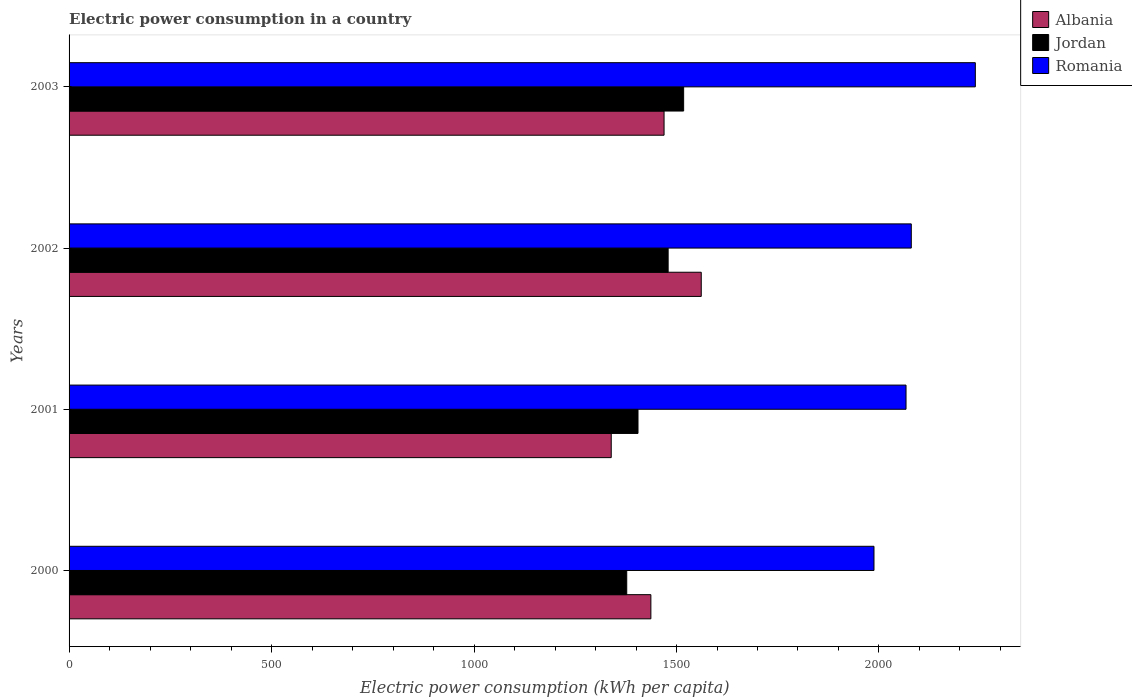How many different coloured bars are there?
Your response must be concise. 3. Are the number of bars per tick equal to the number of legend labels?
Provide a short and direct response. Yes. Are the number of bars on each tick of the Y-axis equal?
Keep it short and to the point. Yes. How many bars are there on the 2nd tick from the top?
Give a very brief answer. 3. What is the label of the 1st group of bars from the top?
Make the answer very short. 2003. What is the electric power consumption in in Romania in 2002?
Keep it short and to the point. 2079.8. Across all years, what is the maximum electric power consumption in in Romania?
Your answer should be compact. 2237.94. Across all years, what is the minimum electric power consumption in in Albania?
Give a very brief answer. 1338.81. What is the total electric power consumption in in Albania in the graph?
Provide a succinct answer. 5805.9. What is the difference between the electric power consumption in in Albania in 2000 and that in 2001?
Ensure brevity in your answer.  97.89. What is the difference between the electric power consumption in in Romania in 2001 and the electric power consumption in in Albania in 2003?
Your response must be concise. 597.52. What is the average electric power consumption in in Romania per year?
Provide a short and direct response. 2093.04. In the year 2000, what is the difference between the electric power consumption in in Albania and electric power consumption in in Jordan?
Your answer should be compact. 59.59. In how many years, is the electric power consumption in in Albania greater than 1800 kWh per capita?
Your answer should be very brief. 0. What is the ratio of the electric power consumption in in Albania in 2000 to that in 2003?
Offer a very short reply. 0.98. Is the difference between the electric power consumption in in Albania in 2000 and 2002 greater than the difference between the electric power consumption in in Jordan in 2000 and 2002?
Offer a terse response. No. What is the difference between the highest and the second highest electric power consumption in in Albania?
Keep it short and to the point. 91.86. What is the difference between the highest and the lowest electric power consumption in in Jordan?
Your response must be concise. 140.51. Is the sum of the electric power consumption in in Albania in 2000 and 2003 greater than the maximum electric power consumption in in Romania across all years?
Offer a very short reply. Yes. What does the 3rd bar from the top in 2000 represents?
Keep it short and to the point. Albania. What does the 2nd bar from the bottom in 2001 represents?
Ensure brevity in your answer.  Jordan. How many bars are there?
Provide a short and direct response. 12. Are all the bars in the graph horizontal?
Your answer should be very brief. Yes. How many years are there in the graph?
Your response must be concise. 4. What is the difference between two consecutive major ticks on the X-axis?
Provide a succinct answer. 500. Are the values on the major ticks of X-axis written in scientific E-notation?
Keep it short and to the point. No. Does the graph contain any zero values?
Your response must be concise. No. Does the graph contain grids?
Your answer should be very brief. No. Where does the legend appear in the graph?
Your answer should be very brief. Top right. How many legend labels are there?
Your answer should be very brief. 3. What is the title of the graph?
Provide a short and direct response. Electric power consumption in a country. Does "Benin" appear as one of the legend labels in the graph?
Make the answer very short. No. What is the label or title of the X-axis?
Offer a very short reply. Electric power consumption (kWh per capita). What is the label or title of the Y-axis?
Provide a short and direct response. Years. What is the Electric power consumption (kWh per capita) in Albania in 2000?
Give a very brief answer. 1436.7. What is the Electric power consumption (kWh per capita) of Jordan in 2000?
Give a very brief answer. 1377.11. What is the Electric power consumption (kWh per capita) in Romania in 2000?
Provide a short and direct response. 1987.66. What is the Electric power consumption (kWh per capita) in Albania in 2001?
Offer a very short reply. 1338.81. What is the Electric power consumption (kWh per capita) of Jordan in 2001?
Give a very brief answer. 1404.92. What is the Electric power consumption (kWh per capita) of Romania in 2001?
Your answer should be very brief. 2066.78. What is the Electric power consumption (kWh per capita) of Albania in 2002?
Offer a terse response. 1561.12. What is the Electric power consumption (kWh per capita) in Jordan in 2002?
Provide a succinct answer. 1479.36. What is the Electric power consumption (kWh per capita) in Romania in 2002?
Give a very brief answer. 2079.8. What is the Electric power consumption (kWh per capita) of Albania in 2003?
Provide a short and direct response. 1469.26. What is the Electric power consumption (kWh per capita) in Jordan in 2003?
Your answer should be compact. 1517.62. What is the Electric power consumption (kWh per capita) of Romania in 2003?
Offer a very short reply. 2237.94. Across all years, what is the maximum Electric power consumption (kWh per capita) of Albania?
Keep it short and to the point. 1561.12. Across all years, what is the maximum Electric power consumption (kWh per capita) in Jordan?
Your response must be concise. 1517.62. Across all years, what is the maximum Electric power consumption (kWh per capita) in Romania?
Give a very brief answer. 2237.94. Across all years, what is the minimum Electric power consumption (kWh per capita) of Albania?
Offer a very short reply. 1338.81. Across all years, what is the minimum Electric power consumption (kWh per capita) of Jordan?
Offer a very short reply. 1377.11. Across all years, what is the minimum Electric power consumption (kWh per capita) of Romania?
Your answer should be compact. 1987.66. What is the total Electric power consumption (kWh per capita) of Albania in the graph?
Keep it short and to the point. 5805.9. What is the total Electric power consumption (kWh per capita) in Jordan in the graph?
Ensure brevity in your answer.  5779.01. What is the total Electric power consumption (kWh per capita) of Romania in the graph?
Make the answer very short. 8372.18. What is the difference between the Electric power consumption (kWh per capita) of Albania in 2000 and that in 2001?
Your answer should be very brief. 97.89. What is the difference between the Electric power consumption (kWh per capita) in Jordan in 2000 and that in 2001?
Your answer should be very brief. -27.81. What is the difference between the Electric power consumption (kWh per capita) in Romania in 2000 and that in 2001?
Keep it short and to the point. -79.12. What is the difference between the Electric power consumption (kWh per capita) of Albania in 2000 and that in 2002?
Provide a short and direct response. -124.42. What is the difference between the Electric power consumption (kWh per capita) of Jordan in 2000 and that in 2002?
Provide a succinct answer. -102.25. What is the difference between the Electric power consumption (kWh per capita) of Romania in 2000 and that in 2002?
Ensure brevity in your answer.  -92.14. What is the difference between the Electric power consumption (kWh per capita) of Albania in 2000 and that in 2003?
Provide a succinct answer. -32.57. What is the difference between the Electric power consumption (kWh per capita) in Jordan in 2000 and that in 2003?
Your answer should be very brief. -140.51. What is the difference between the Electric power consumption (kWh per capita) in Romania in 2000 and that in 2003?
Make the answer very short. -250.28. What is the difference between the Electric power consumption (kWh per capita) in Albania in 2001 and that in 2002?
Offer a very short reply. -222.31. What is the difference between the Electric power consumption (kWh per capita) in Jordan in 2001 and that in 2002?
Offer a terse response. -74.44. What is the difference between the Electric power consumption (kWh per capita) of Romania in 2001 and that in 2002?
Your answer should be compact. -13.01. What is the difference between the Electric power consumption (kWh per capita) in Albania in 2001 and that in 2003?
Your answer should be very brief. -130.45. What is the difference between the Electric power consumption (kWh per capita) of Jordan in 2001 and that in 2003?
Offer a terse response. -112.7. What is the difference between the Electric power consumption (kWh per capita) in Romania in 2001 and that in 2003?
Keep it short and to the point. -171.15. What is the difference between the Electric power consumption (kWh per capita) in Albania in 2002 and that in 2003?
Keep it short and to the point. 91.86. What is the difference between the Electric power consumption (kWh per capita) in Jordan in 2002 and that in 2003?
Offer a very short reply. -38.27. What is the difference between the Electric power consumption (kWh per capita) of Romania in 2002 and that in 2003?
Make the answer very short. -158.14. What is the difference between the Electric power consumption (kWh per capita) in Albania in 2000 and the Electric power consumption (kWh per capita) in Jordan in 2001?
Keep it short and to the point. 31.78. What is the difference between the Electric power consumption (kWh per capita) in Albania in 2000 and the Electric power consumption (kWh per capita) in Romania in 2001?
Offer a terse response. -630.09. What is the difference between the Electric power consumption (kWh per capita) of Jordan in 2000 and the Electric power consumption (kWh per capita) of Romania in 2001?
Offer a terse response. -689.67. What is the difference between the Electric power consumption (kWh per capita) in Albania in 2000 and the Electric power consumption (kWh per capita) in Jordan in 2002?
Offer a very short reply. -42.66. What is the difference between the Electric power consumption (kWh per capita) in Albania in 2000 and the Electric power consumption (kWh per capita) in Romania in 2002?
Your answer should be very brief. -643.1. What is the difference between the Electric power consumption (kWh per capita) of Jordan in 2000 and the Electric power consumption (kWh per capita) of Romania in 2002?
Ensure brevity in your answer.  -702.69. What is the difference between the Electric power consumption (kWh per capita) of Albania in 2000 and the Electric power consumption (kWh per capita) of Jordan in 2003?
Provide a succinct answer. -80.92. What is the difference between the Electric power consumption (kWh per capita) in Albania in 2000 and the Electric power consumption (kWh per capita) in Romania in 2003?
Ensure brevity in your answer.  -801.24. What is the difference between the Electric power consumption (kWh per capita) in Jordan in 2000 and the Electric power consumption (kWh per capita) in Romania in 2003?
Your answer should be compact. -860.83. What is the difference between the Electric power consumption (kWh per capita) of Albania in 2001 and the Electric power consumption (kWh per capita) of Jordan in 2002?
Make the answer very short. -140.54. What is the difference between the Electric power consumption (kWh per capita) in Albania in 2001 and the Electric power consumption (kWh per capita) in Romania in 2002?
Keep it short and to the point. -740.98. What is the difference between the Electric power consumption (kWh per capita) in Jordan in 2001 and the Electric power consumption (kWh per capita) in Romania in 2002?
Your response must be concise. -674.87. What is the difference between the Electric power consumption (kWh per capita) in Albania in 2001 and the Electric power consumption (kWh per capita) in Jordan in 2003?
Ensure brevity in your answer.  -178.81. What is the difference between the Electric power consumption (kWh per capita) of Albania in 2001 and the Electric power consumption (kWh per capita) of Romania in 2003?
Provide a succinct answer. -899.12. What is the difference between the Electric power consumption (kWh per capita) of Jordan in 2001 and the Electric power consumption (kWh per capita) of Romania in 2003?
Your answer should be very brief. -833.02. What is the difference between the Electric power consumption (kWh per capita) in Albania in 2002 and the Electric power consumption (kWh per capita) in Jordan in 2003?
Make the answer very short. 43.5. What is the difference between the Electric power consumption (kWh per capita) in Albania in 2002 and the Electric power consumption (kWh per capita) in Romania in 2003?
Offer a terse response. -676.82. What is the difference between the Electric power consumption (kWh per capita) of Jordan in 2002 and the Electric power consumption (kWh per capita) of Romania in 2003?
Your answer should be very brief. -758.58. What is the average Electric power consumption (kWh per capita) of Albania per year?
Give a very brief answer. 1451.47. What is the average Electric power consumption (kWh per capita) in Jordan per year?
Provide a succinct answer. 1444.75. What is the average Electric power consumption (kWh per capita) of Romania per year?
Provide a short and direct response. 2093.04. In the year 2000, what is the difference between the Electric power consumption (kWh per capita) of Albania and Electric power consumption (kWh per capita) of Jordan?
Your response must be concise. 59.59. In the year 2000, what is the difference between the Electric power consumption (kWh per capita) in Albania and Electric power consumption (kWh per capita) in Romania?
Give a very brief answer. -550.96. In the year 2000, what is the difference between the Electric power consumption (kWh per capita) of Jordan and Electric power consumption (kWh per capita) of Romania?
Your answer should be very brief. -610.55. In the year 2001, what is the difference between the Electric power consumption (kWh per capita) in Albania and Electric power consumption (kWh per capita) in Jordan?
Make the answer very short. -66.11. In the year 2001, what is the difference between the Electric power consumption (kWh per capita) of Albania and Electric power consumption (kWh per capita) of Romania?
Your answer should be compact. -727.97. In the year 2001, what is the difference between the Electric power consumption (kWh per capita) in Jordan and Electric power consumption (kWh per capita) in Romania?
Offer a very short reply. -661.86. In the year 2002, what is the difference between the Electric power consumption (kWh per capita) of Albania and Electric power consumption (kWh per capita) of Jordan?
Provide a succinct answer. 81.77. In the year 2002, what is the difference between the Electric power consumption (kWh per capita) in Albania and Electric power consumption (kWh per capita) in Romania?
Ensure brevity in your answer.  -518.67. In the year 2002, what is the difference between the Electric power consumption (kWh per capita) in Jordan and Electric power consumption (kWh per capita) in Romania?
Provide a succinct answer. -600.44. In the year 2003, what is the difference between the Electric power consumption (kWh per capita) in Albania and Electric power consumption (kWh per capita) in Jordan?
Keep it short and to the point. -48.36. In the year 2003, what is the difference between the Electric power consumption (kWh per capita) in Albania and Electric power consumption (kWh per capita) in Romania?
Offer a terse response. -768.67. In the year 2003, what is the difference between the Electric power consumption (kWh per capita) in Jordan and Electric power consumption (kWh per capita) in Romania?
Offer a terse response. -720.32. What is the ratio of the Electric power consumption (kWh per capita) of Albania in 2000 to that in 2001?
Keep it short and to the point. 1.07. What is the ratio of the Electric power consumption (kWh per capita) in Jordan in 2000 to that in 2001?
Offer a very short reply. 0.98. What is the ratio of the Electric power consumption (kWh per capita) of Romania in 2000 to that in 2001?
Keep it short and to the point. 0.96. What is the ratio of the Electric power consumption (kWh per capita) of Albania in 2000 to that in 2002?
Keep it short and to the point. 0.92. What is the ratio of the Electric power consumption (kWh per capita) of Jordan in 2000 to that in 2002?
Give a very brief answer. 0.93. What is the ratio of the Electric power consumption (kWh per capita) of Romania in 2000 to that in 2002?
Your answer should be compact. 0.96. What is the ratio of the Electric power consumption (kWh per capita) of Albania in 2000 to that in 2003?
Offer a very short reply. 0.98. What is the ratio of the Electric power consumption (kWh per capita) of Jordan in 2000 to that in 2003?
Offer a terse response. 0.91. What is the ratio of the Electric power consumption (kWh per capita) in Romania in 2000 to that in 2003?
Offer a terse response. 0.89. What is the ratio of the Electric power consumption (kWh per capita) in Albania in 2001 to that in 2002?
Make the answer very short. 0.86. What is the ratio of the Electric power consumption (kWh per capita) in Jordan in 2001 to that in 2002?
Offer a terse response. 0.95. What is the ratio of the Electric power consumption (kWh per capita) of Albania in 2001 to that in 2003?
Keep it short and to the point. 0.91. What is the ratio of the Electric power consumption (kWh per capita) in Jordan in 2001 to that in 2003?
Ensure brevity in your answer.  0.93. What is the ratio of the Electric power consumption (kWh per capita) of Romania in 2001 to that in 2003?
Keep it short and to the point. 0.92. What is the ratio of the Electric power consumption (kWh per capita) of Albania in 2002 to that in 2003?
Make the answer very short. 1.06. What is the ratio of the Electric power consumption (kWh per capita) in Jordan in 2002 to that in 2003?
Offer a terse response. 0.97. What is the ratio of the Electric power consumption (kWh per capita) of Romania in 2002 to that in 2003?
Keep it short and to the point. 0.93. What is the difference between the highest and the second highest Electric power consumption (kWh per capita) of Albania?
Your answer should be compact. 91.86. What is the difference between the highest and the second highest Electric power consumption (kWh per capita) in Jordan?
Provide a succinct answer. 38.27. What is the difference between the highest and the second highest Electric power consumption (kWh per capita) of Romania?
Offer a very short reply. 158.14. What is the difference between the highest and the lowest Electric power consumption (kWh per capita) of Albania?
Ensure brevity in your answer.  222.31. What is the difference between the highest and the lowest Electric power consumption (kWh per capita) of Jordan?
Your answer should be compact. 140.51. What is the difference between the highest and the lowest Electric power consumption (kWh per capita) of Romania?
Offer a very short reply. 250.28. 